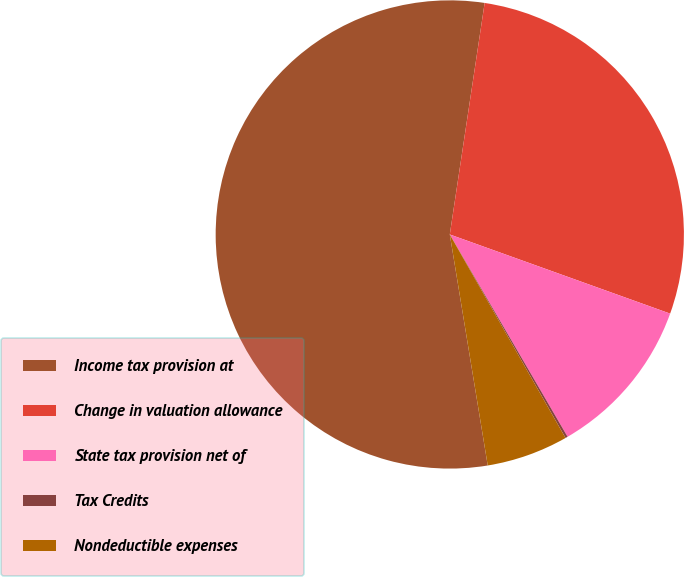Convert chart. <chart><loc_0><loc_0><loc_500><loc_500><pie_chart><fcel>Income tax provision at<fcel>Change in valuation allowance<fcel>State tax provision net of<fcel>Tax Credits<fcel>Nondeductible expenses<nl><fcel>54.97%<fcel>28.11%<fcel>11.12%<fcel>0.16%<fcel>5.64%<nl></chart> 